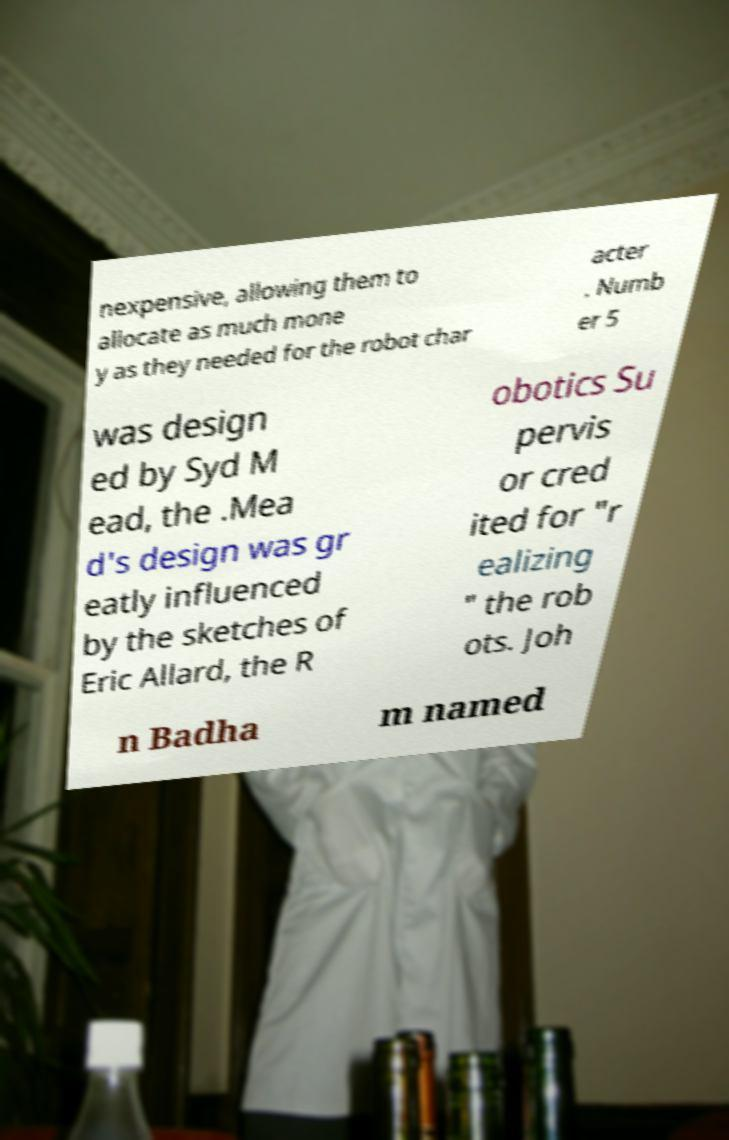Could you assist in decoding the text presented in this image and type it out clearly? nexpensive, allowing them to allocate as much mone y as they needed for the robot char acter . Numb er 5 was design ed by Syd M ead, the .Mea d's design was gr eatly influenced by the sketches of Eric Allard, the R obotics Su pervis or cred ited for "r ealizing " the rob ots. Joh n Badha m named 